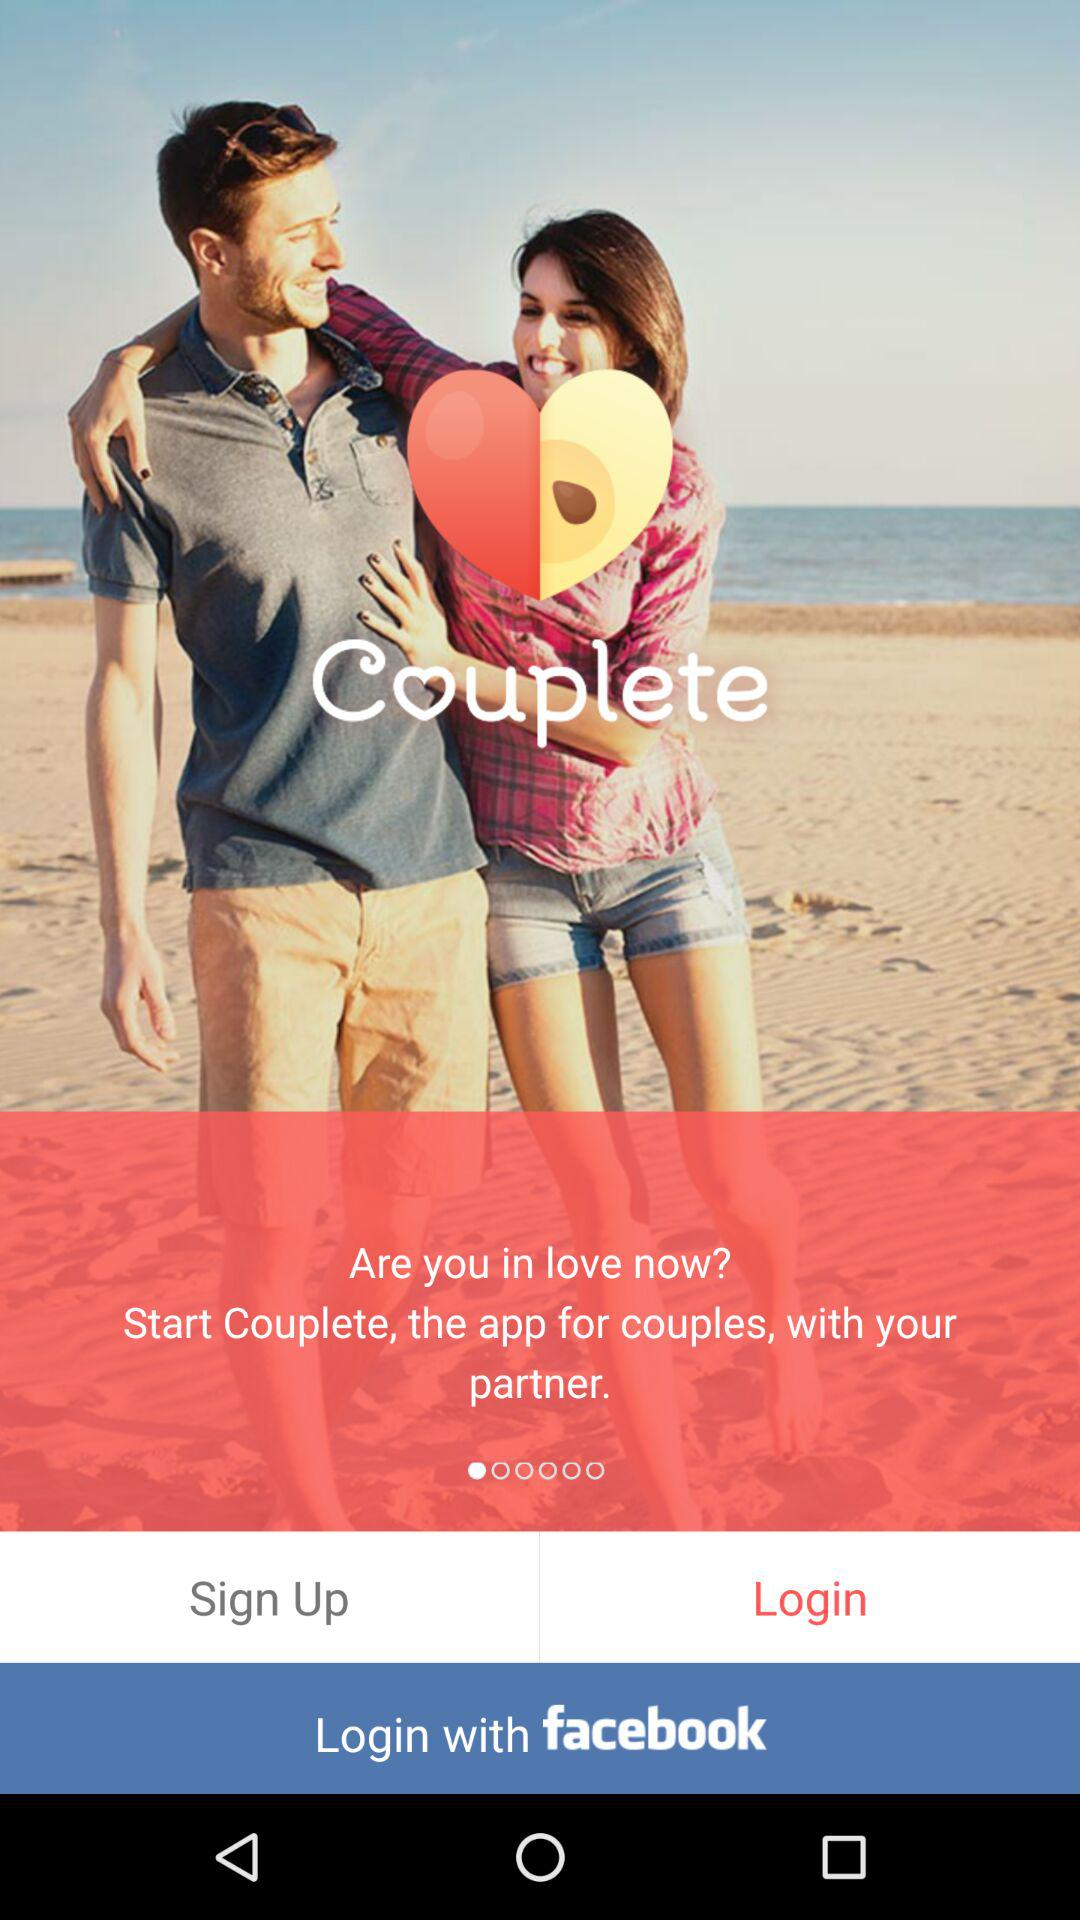What is the application name? The application name is "Couplete". 